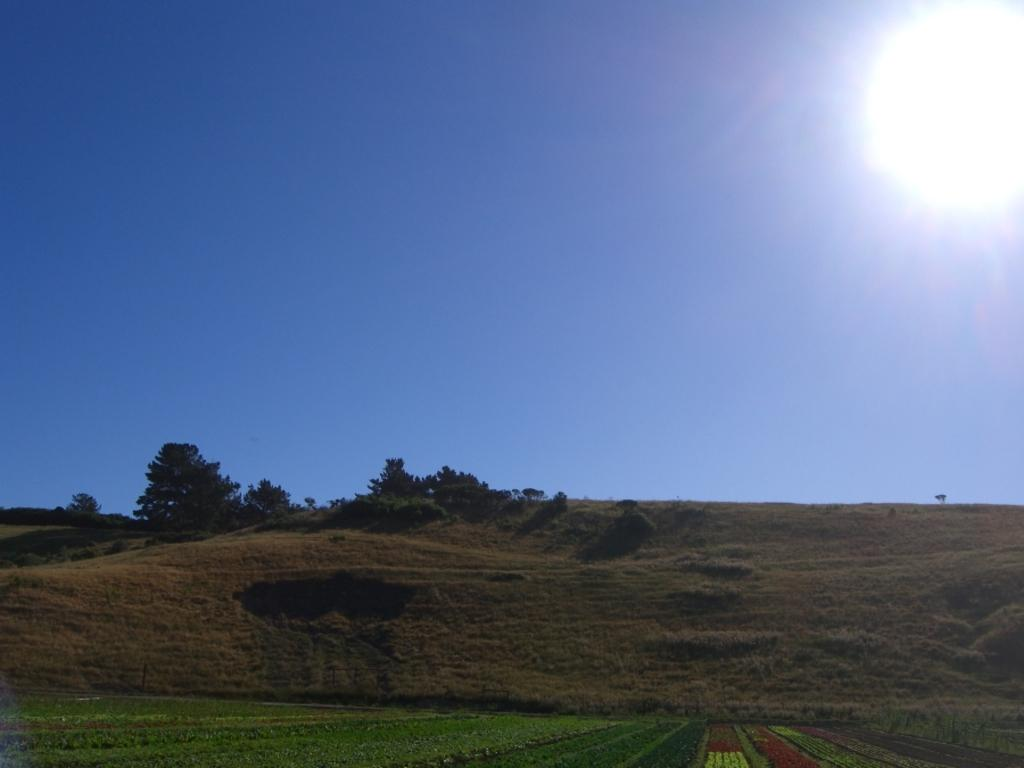Where was the image taken? The image was clicked outside the city. What can be seen in the foreground of the image? There is green grass in the foreground of the image. What is located in the center of the image? There are plants and a tree in the center of the image. What is visible in the background of the image? The sky is visible in the background of the image. Can the sun be seen in the image? Yes, the sun is observable in the sky. What type of net can be seen hanging from the tree in the image? There is no net present in the image; it features plants and a tree in the center. What kind of loaf is being served in the lunchroom in the image? There is no lunchroom or loaf present in the image. 